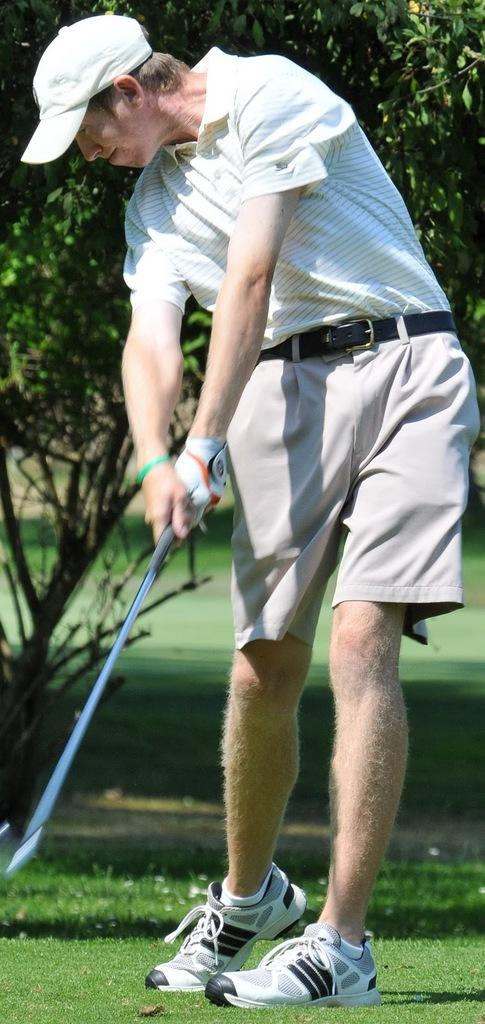Who or what is the main subject in the image? There is a person in the image. What is the person holding in the image? The person is holding a stick. What type of clothing is the person wearing on their head? The person is wearing a cap. What type of clothing is the person wearing on their hands? The person is wearing gloves. What type of surface is the person standing on in the image? The person is standing on the grass. What can be seen in the background of the image? There is a tree in the background of the image. What type of instrument is the person playing in the image? There is no instrument present in the image; the person is holding a stick. How does the person stop the grass from growing in the image? The person is not stopping the grass from growing in the image; they are simply standing on it. 